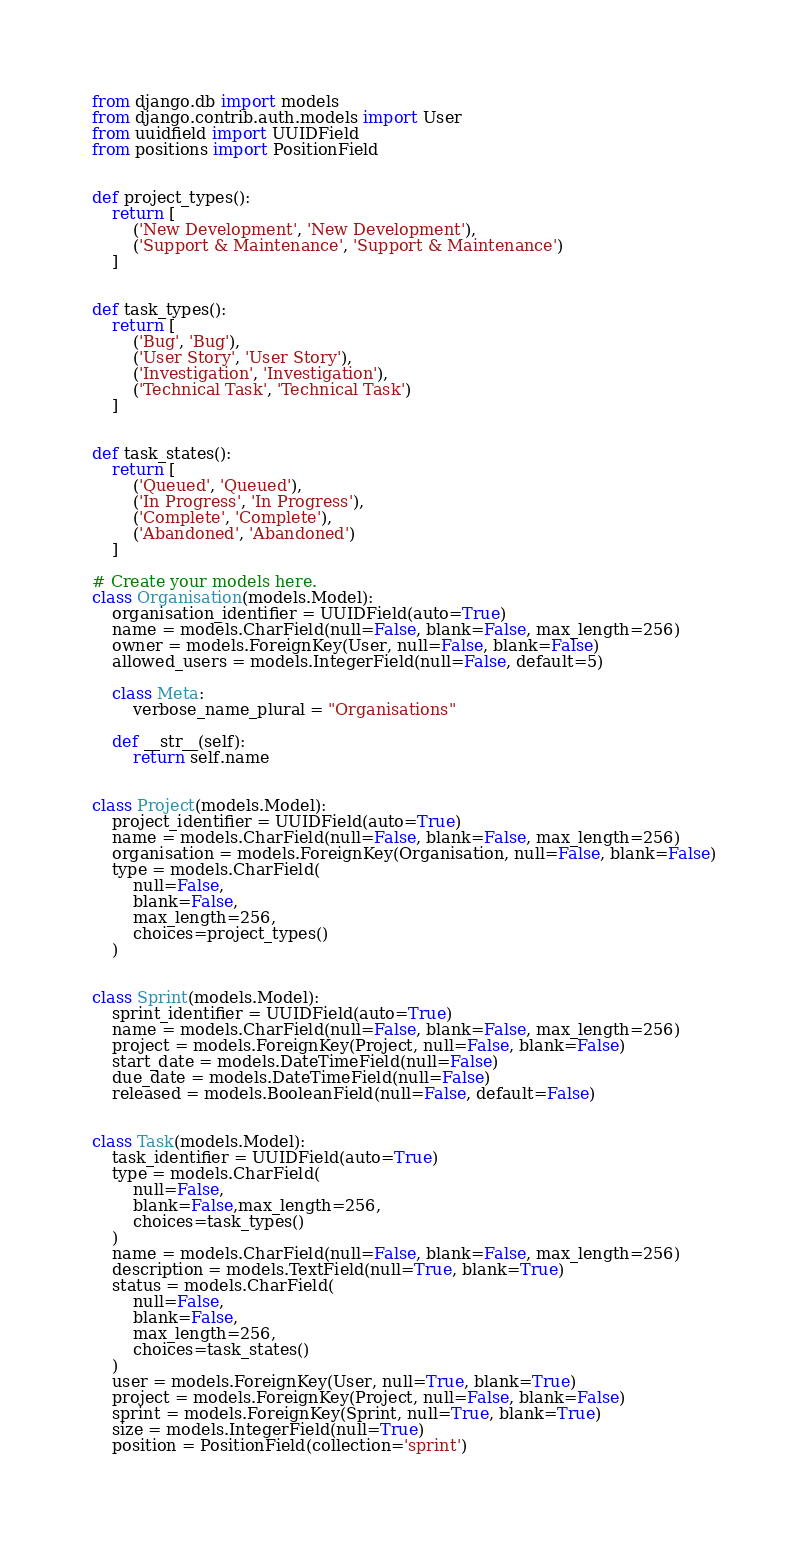<code> <loc_0><loc_0><loc_500><loc_500><_Python_>from django.db import models
from django.contrib.auth.models import User
from uuidfield import UUIDField
from positions import PositionField


def project_types():
    return [
        ('New Development', 'New Development'),
        ('Support & Maintenance', 'Support & Maintenance')
    ]


def task_types():
    return [
        ('Bug', 'Bug'),
        ('User Story', 'User Story'),
        ('Investigation', 'Investigation'),
        ('Technical Task', 'Technical Task')
    ]


def task_states():
    return [
        ('Queued', 'Queued'),
        ('In Progress', 'In Progress'),
        ('Complete', 'Complete'),
        ('Abandoned', 'Abandoned')
    ]

# Create your models here.
class Organisation(models.Model):
    organisation_identifier = UUIDField(auto=True)
    name = models.CharField(null=False, blank=False, max_length=256)
    owner = models.ForeignKey(User, null=False, blank=False)
    allowed_users = models.IntegerField(null=False, default=5)

    class Meta:
        verbose_name_plural = "Organisations"

    def __str__(self):
        return self.name


class Project(models.Model):
    project_identifier = UUIDField(auto=True)
    name = models.CharField(null=False, blank=False, max_length=256)
    organisation = models.ForeignKey(Organisation, null=False, blank=False)
    type = models.CharField(
        null=False,
        blank=False,
        max_length=256,
        choices=project_types()
    )


class Sprint(models.Model):
    sprint_identifier = UUIDField(auto=True)
    name = models.CharField(null=False, blank=False, max_length=256)
    project = models.ForeignKey(Project, null=False, blank=False)
    start_date = models.DateTimeField(null=False)
    due_date = models.DateTimeField(null=False)
    released = models.BooleanField(null=False, default=False)


class Task(models.Model):
    task_identifier = UUIDField(auto=True)
    type = models.CharField(
        null=False,
        blank=False,max_length=256,
        choices=task_types()
    )
    name = models.CharField(null=False, blank=False, max_length=256)
    description = models.TextField(null=True, blank=True)
    status = models.CharField(
        null=False,
        blank=False,
        max_length=256,
        choices=task_states()
    )
    user = models.ForeignKey(User, null=True, blank=True)
    project = models.ForeignKey(Project, null=False, blank=False)
    sprint = models.ForeignKey(Sprint, null=True, blank=True)
    size = models.IntegerField(null=True)
    position = PositionField(collection='sprint')</code> 